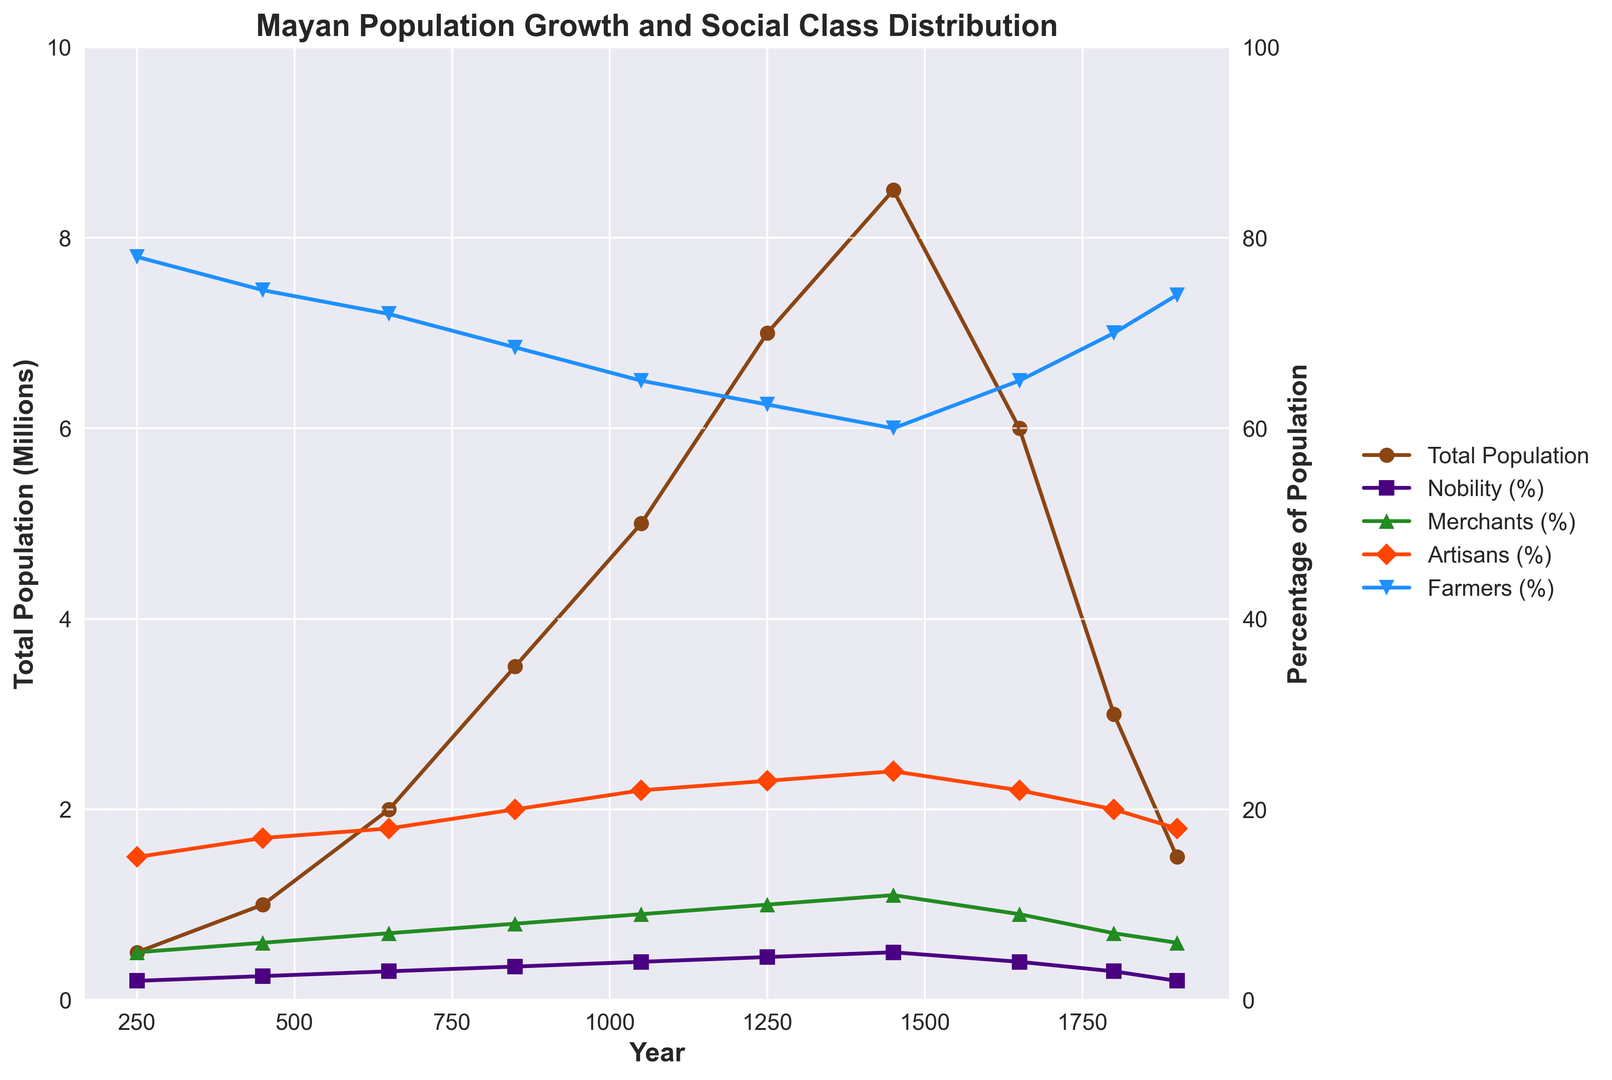What is the highest percentage of Nobility observed over the years? By inspecting the purple line representing Nobility (%) on the secondary axis, the highest point reached is noted. The peak value of the Nobility percentage line occurs around the year 1450 at 5%.
Answer: 5% Between which centuries did the total population more than double? Looking at the brown line representing Total Population on the primary axis, we see a significant rise between 650 (2 million) and 850 (3.5 million), and then again between 1050 (5 million) and 1250 (7 million). Thus, we notice the total population more than doubled between 650 and 850, as well as between 1050 and 1250.
Answer: 650-850 and 1050-1250 How did the percentage of Farmers change from 250 to 1450? By examining the secondary axis and the blue line for Farmers (%), in 250 the Farmers percentage is 78%. By 1450, it decreased to 60%. This shows a decrease of 18% (78% - 60% = 18%).
Answer: Decreased by 18% Which social class's percentage increased the most between 1250 and 1450? Observing the secondary axis, one should compare the lines of each social class. The percentage for Nobility increased from 4.5% to 5% (+0.5%). The percentage for Merchants increased from 10% to 11% (+1%). The percentage for Artisans increased from 23% to 24% (+1%). The percentage for Farmers decreased. Therefore, Merchants and Artisans both increased the most by 1%.
Answer: Merchants and Artisans Which time period saw the sharpest decline in total population? Analyzing the primary axis and the brown line for Total Population, the sharpest decline occurred between 1450 (8.5 million) and 1650 (6 million).
Answer: 1450-1650 If the population trend continued, what might be the estimated total population in the year 2000? The graph shows a fluctuating trend post-1450 with overall decline from 1650 to 1900. Assuming the decline continued in a similar fashion after 1900 (1.5 million), one could estimate a further decrease by applying the trend. A possible estimate for 2000 might be around 1 million, considering the rate of decline slows towards the end.
Answer: Approximately 1 million How does the artisanal class' change compare to the farmers' change between 850 and 1650? From 850 to 1650, the percentage of Artisans increased from 20% to 22% (increase by 2%). Farmers' percentage decreased from 68.5% to 65% (decrease by 3.5%). Thus, while Artisans' percentage saw a rise, Farmers experienced a more significant decrease.
Answer: Artisans increased slightly, Farmers decreased What is the difference in percentage between Nobility and Farmers in 1050? Referring to the secondary axis for the year 1050, the percentage of Nobility is 4%, and for Farmers, it is 65%. The difference is 65% - 4% = 61%.
Answer: 61% Which class had the least percentage change over time? By evaluating the lines on the secondary y-axis, Nobility (%) shows relatively minimal fluctuation compared to other classes, ranging from 2% to 5%.
Answer: Nobility 